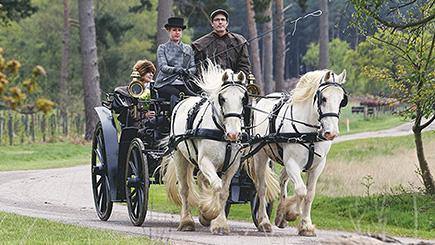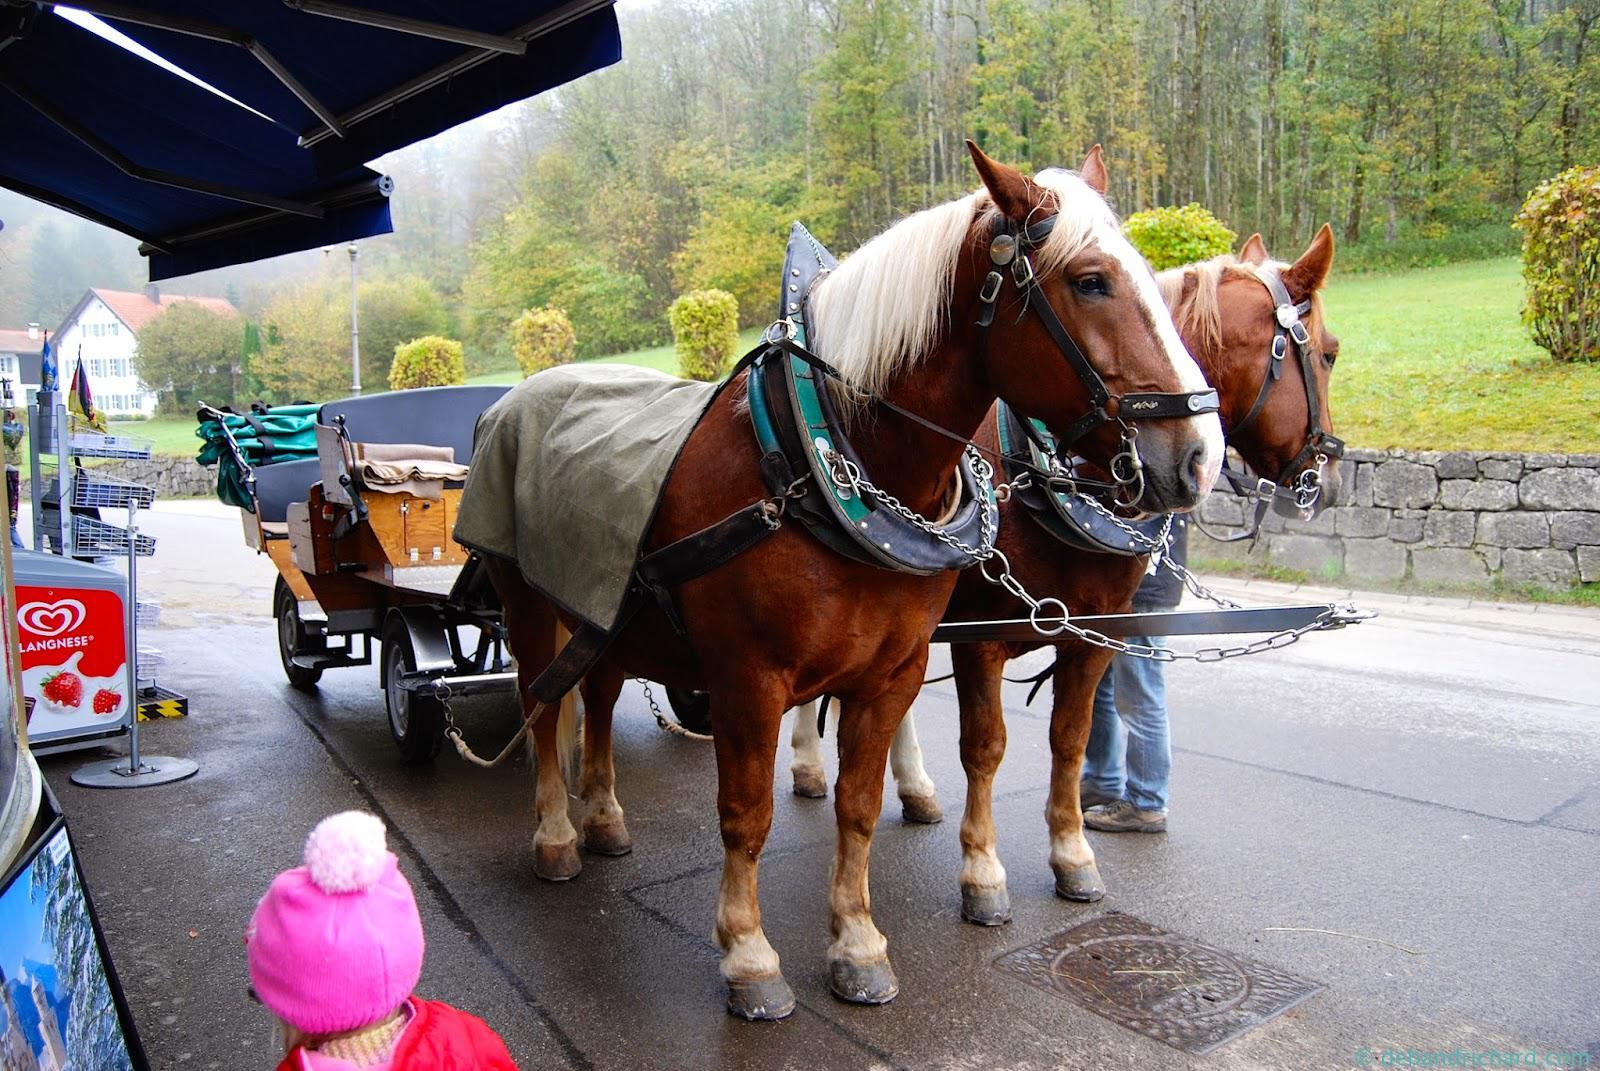The first image is the image on the left, the second image is the image on the right. Examine the images to the left and right. Is the description "At least one image shows a cart pulled by exactly two white horses." accurate? Answer yes or no. Yes. The first image is the image on the left, the second image is the image on the right. Considering the images on both sides, is "There are two white horses in the image on the left." valid? Answer yes or no. Yes. 